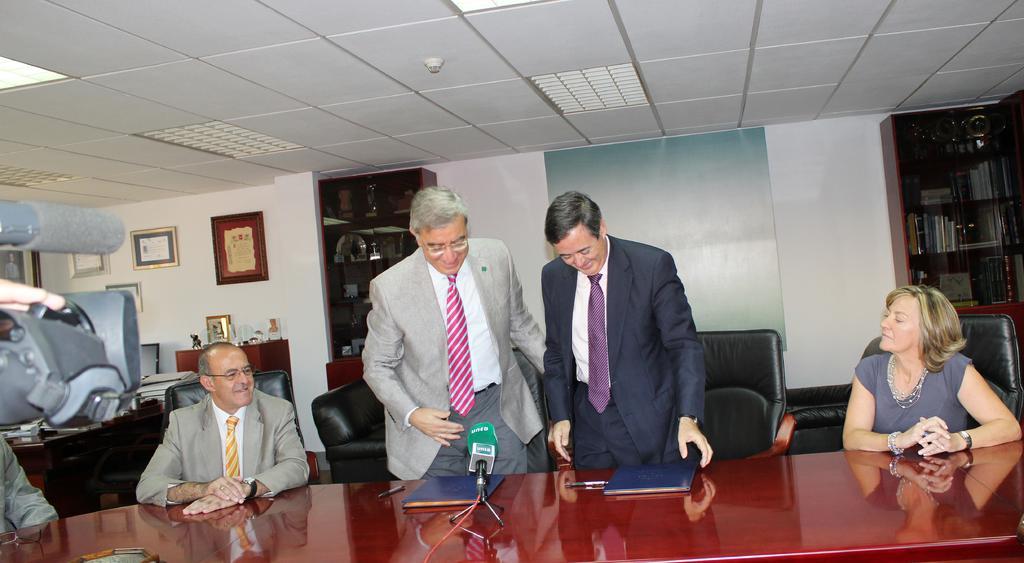Please provide a concise description of this image. In the given image we can see that, there are two persons standing and three of them are sitting on chair. This is a table on which mic and books are kept. This is a wall and photo frame is stick to it. These are the lights. 